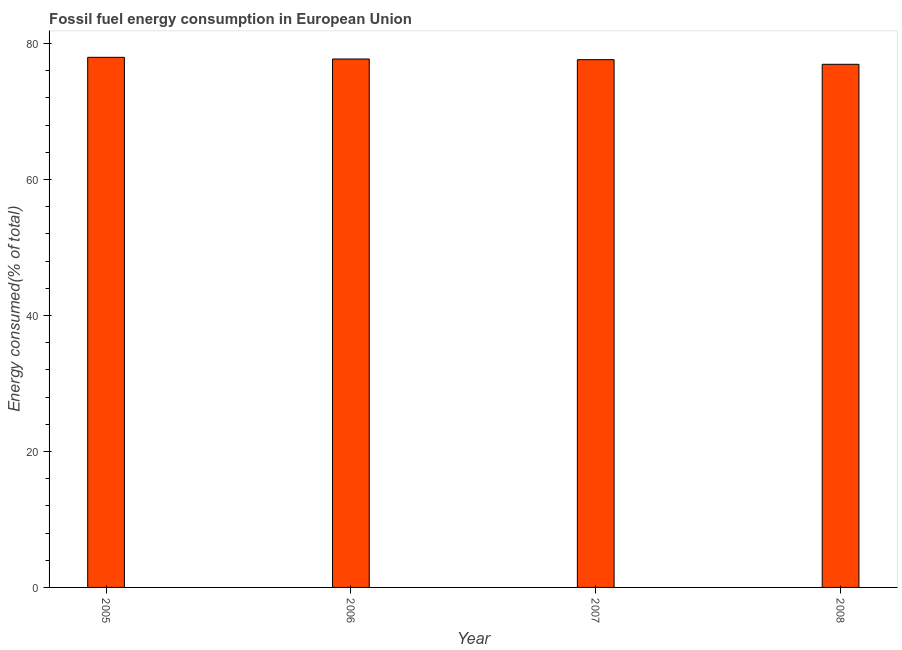Does the graph contain grids?
Ensure brevity in your answer.  No. What is the title of the graph?
Your answer should be compact. Fossil fuel energy consumption in European Union. What is the label or title of the X-axis?
Your response must be concise. Year. What is the label or title of the Y-axis?
Your response must be concise. Energy consumed(% of total). What is the fossil fuel energy consumption in 2008?
Ensure brevity in your answer.  76.95. Across all years, what is the maximum fossil fuel energy consumption?
Provide a short and direct response. 77.98. Across all years, what is the minimum fossil fuel energy consumption?
Keep it short and to the point. 76.95. In which year was the fossil fuel energy consumption maximum?
Make the answer very short. 2005. In which year was the fossil fuel energy consumption minimum?
Make the answer very short. 2008. What is the sum of the fossil fuel energy consumption?
Your answer should be very brief. 310.3. What is the difference between the fossil fuel energy consumption in 2006 and 2008?
Provide a short and direct response. 0.78. What is the average fossil fuel energy consumption per year?
Make the answer very short. 77.58. What is the median fossil fuel energy consumption?
Your answer should be compact. 77.68. Do a majority of the years between 2008 and 2007 (inclusive) have fossil fuel energy consumption greater than 4 %?
Provide a short and direct response. No. What is the ratio of the fossil fuel energy consumption in 2007 to that in 2008?
Provide a short and direct response. 1.01. Is the difference between the fossil fuel energy consumption in 2005 and 2006 greater than the difference between any two years?
Ensure brevity in your answer.  No. What is the difference between the highest and the second highest fossil fuel energy consumption?
Offer a very short reply. 0.25. Is the sum of the fossil fuel energy consumption in 2005 and 2006 greater than the maximum fossil fuel energy consumption across all years?
Offer a terse response. Yes. How many bars are there?
Ensure brevity in your answer.  4. How many years are there in the graph?
Offer a terse response. 4. Are the values on the major ticks of Y-axis written in scientific E-notation?
Keep it short and to the point. No. What is the Energy consumed(% of total) in 2005?
Keep it short and to the point. 77.98. What is the Energy consumed(% of total) of 2006?
Your answer should be very brief. 77.73. What is the Energy consumed(% of total) of 2007?
Keep it short and to the point. 77.63. What is the Energy consumed(% of total) in 2008?
Your answer should be compact. 76.95. What is the difference between the Energy consumed(% of total) in 2005 and 2006?
Offer a very short reply. 0.25. What is the difference between the Energy consumed(% of total) in 2005 and 2007?
Provide a succinct answer. 0.34. What is the difference between the Energy consumed(% of total) in 2005 and 2008?
Your answer should be very brief. 1.03. What is the difference between the Energy consumed(% of total) in 2006 and 2007?
Offer a terse response. 0.1. What is the difference between the Energy consumed(% of total) in 2006 and 2008?
Your answer should be compact. 0.78. What is the difference between the Energy consumed(% of total) in 2007 and 2008?
Your answer should be very brief. 0.68. What is the ratio of the Energy consumed(% of total) in 2005 to that in 2008?
Provide a short and direct response. 1.01. What is the ratio of the Energy consumed(% of total) in 2007 to that in 2008?
Ensure brevity in your answer.  1.01. 